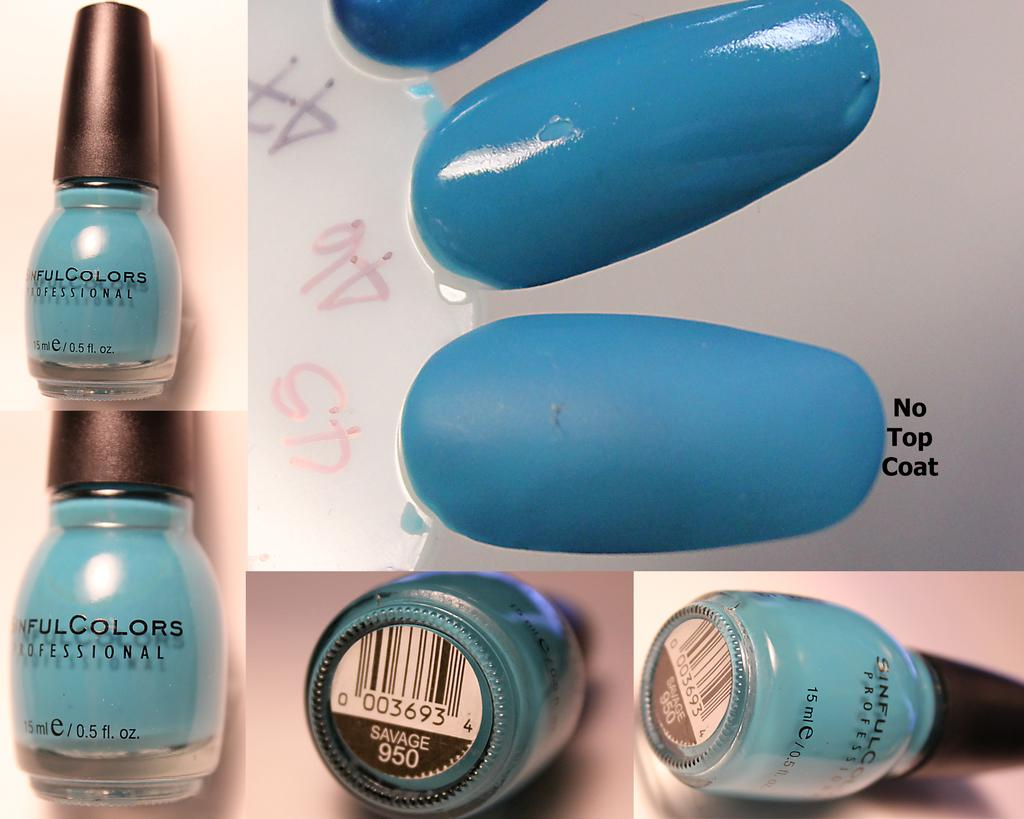Provide a one-sentence caption for the provided image. A bottle of Sinful Colors nail polish is displayed in the color Savage. 